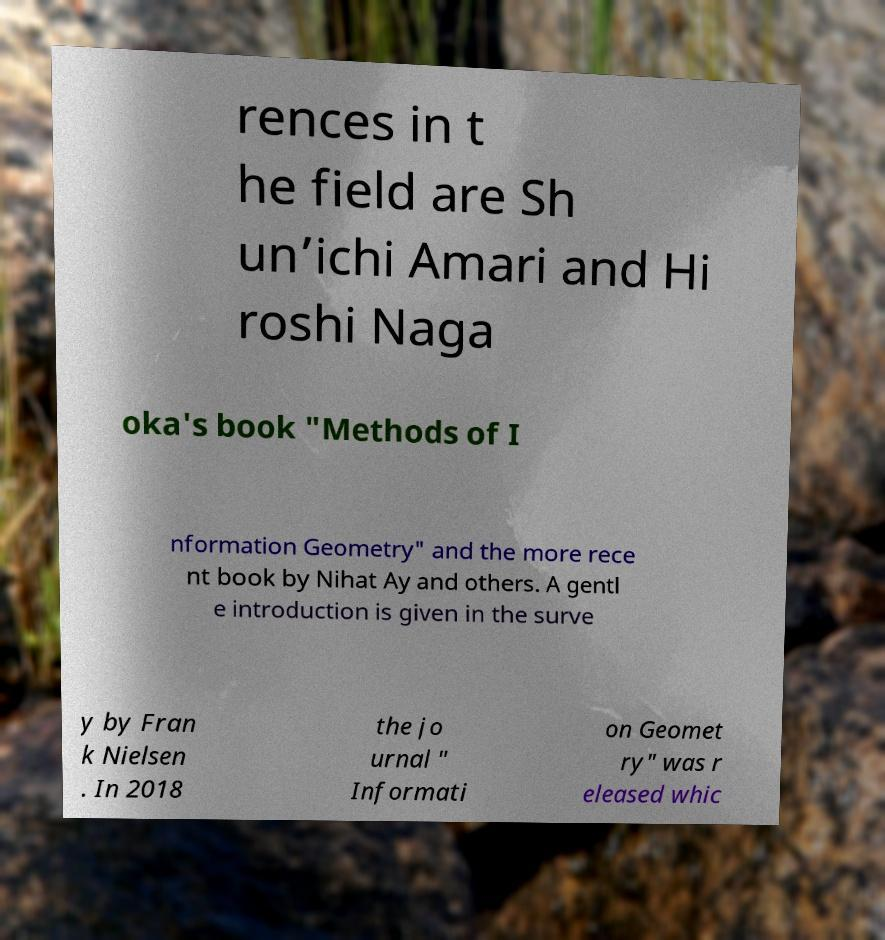Please read and relay the text visible in this image. What does it say? rences in t he field are Sh un’ichi Amari and Hi roshi Naga oka's book "Methods of I nformation Geometry" and the more rece nt book by Nihat Ay and others. A gentl e introduction is given in the surve y by Fran k Nielsen . In 2018 the jo urnal " Informati on Geomet ry" was r eleased whic 